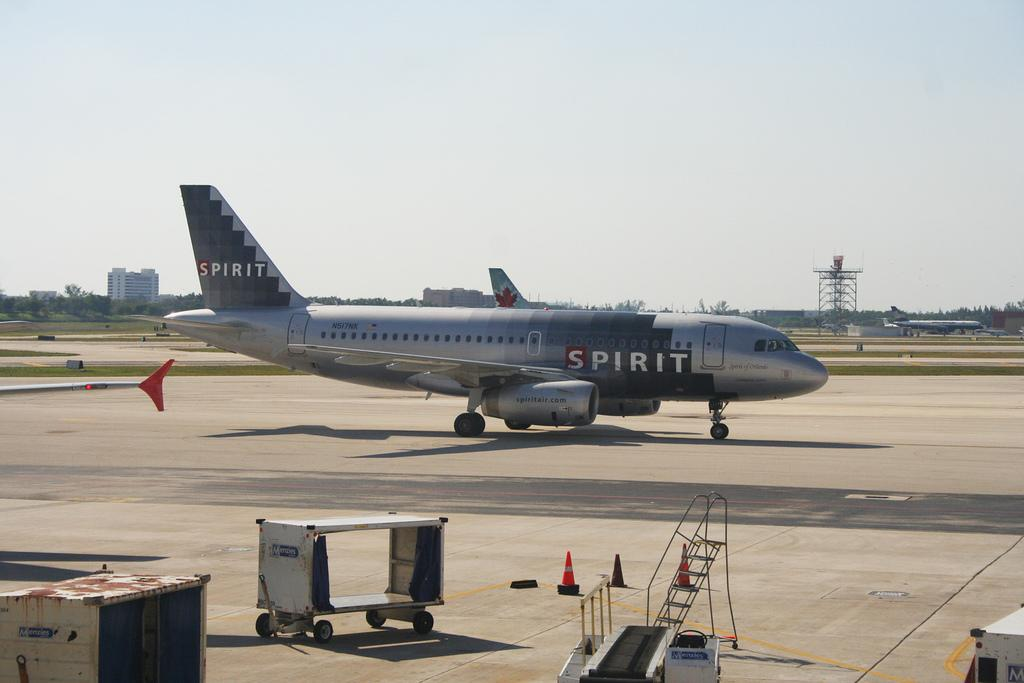<image>
Describe the image concisely. A blue passenger jet is on the tarmac and says Spirit on the side. 